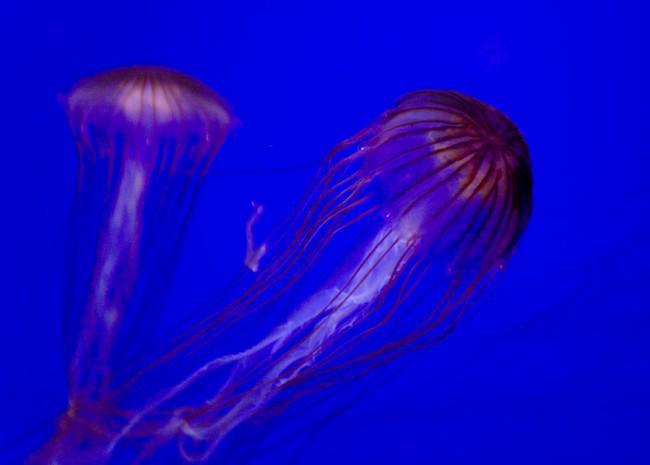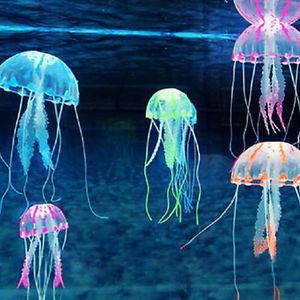The first image is the image on the left, the second image is the image on the right. Considering the images on both sides, is "All the jellyfish in one image are purplish-pink in color." valid? Answer yes or no. Yes. The first image is the image on the left, the second image is the image on the right. Analyze the images presented: Is the assertion "There is at least one orange colored jellyfish." valid? Answer yes or no. Yes. 